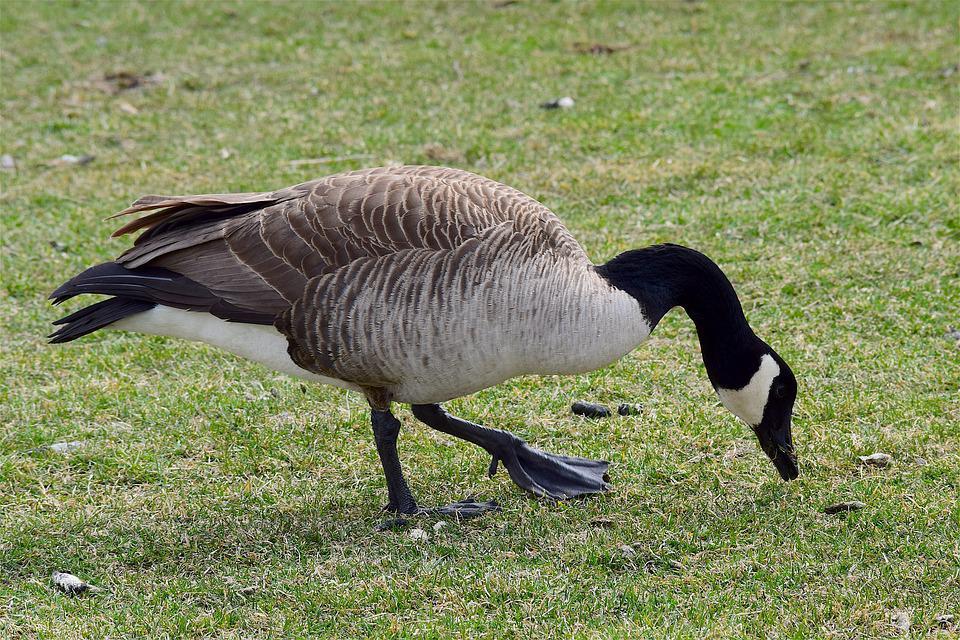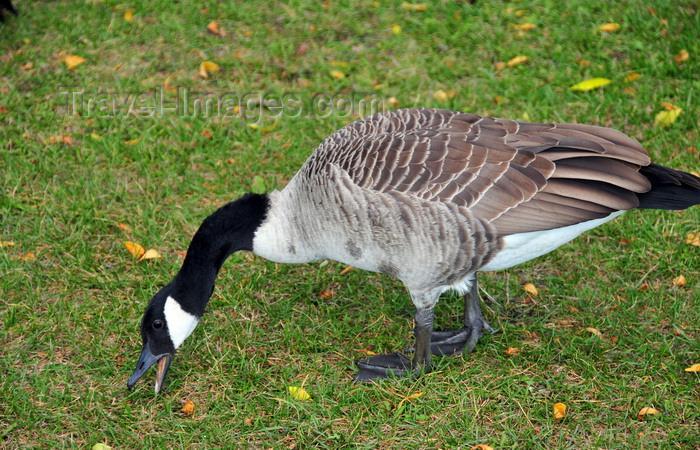The first image is the image on the left, the second image is the image on the right. Given the left and right images, does the statement "The duck in the right image has its beak on the ground." hold true? Answer yes or no. Yes. The first image is the image on the left, the second image is the image on the right. Considering the images on both sides, is "Each image contains one black-necked goose, and each goose has its neck bent so its beak points downward." valid? Answer yes or no. Yes. 